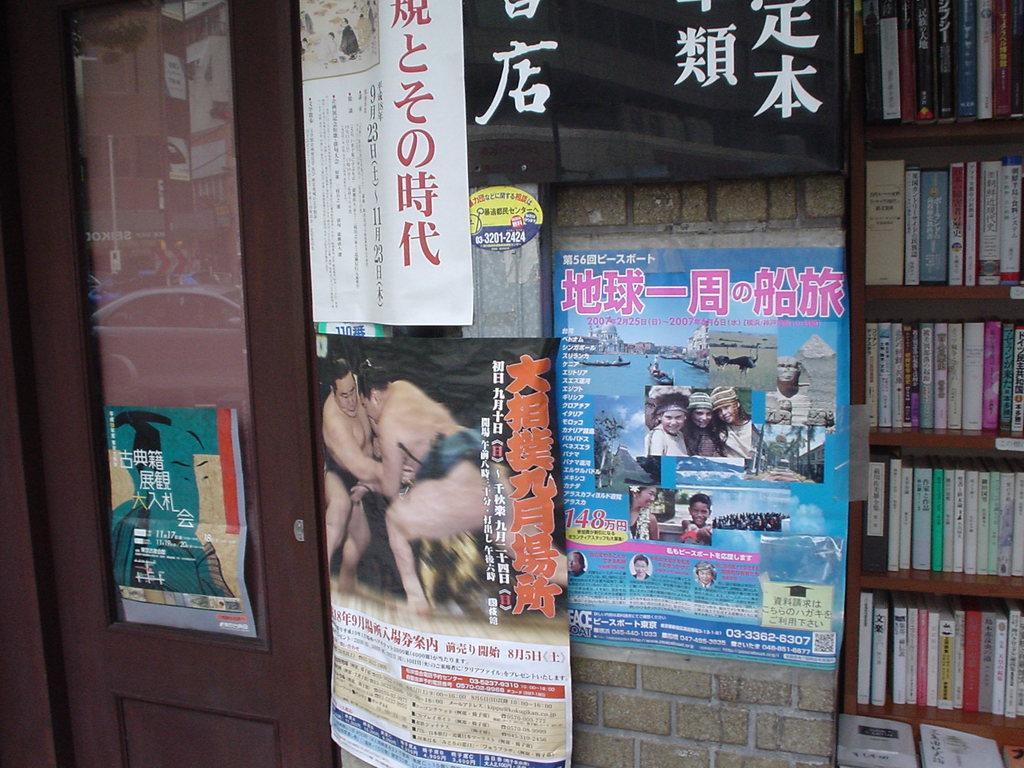Could you give a brief overview of what you see in this image? In this image there are few posts attached to the wall having a door to it. On the door there is a poster attached to it. On the door there is reflection of a car, few vehicles and buildings. Right side of the image there is a rack having few books in it. 